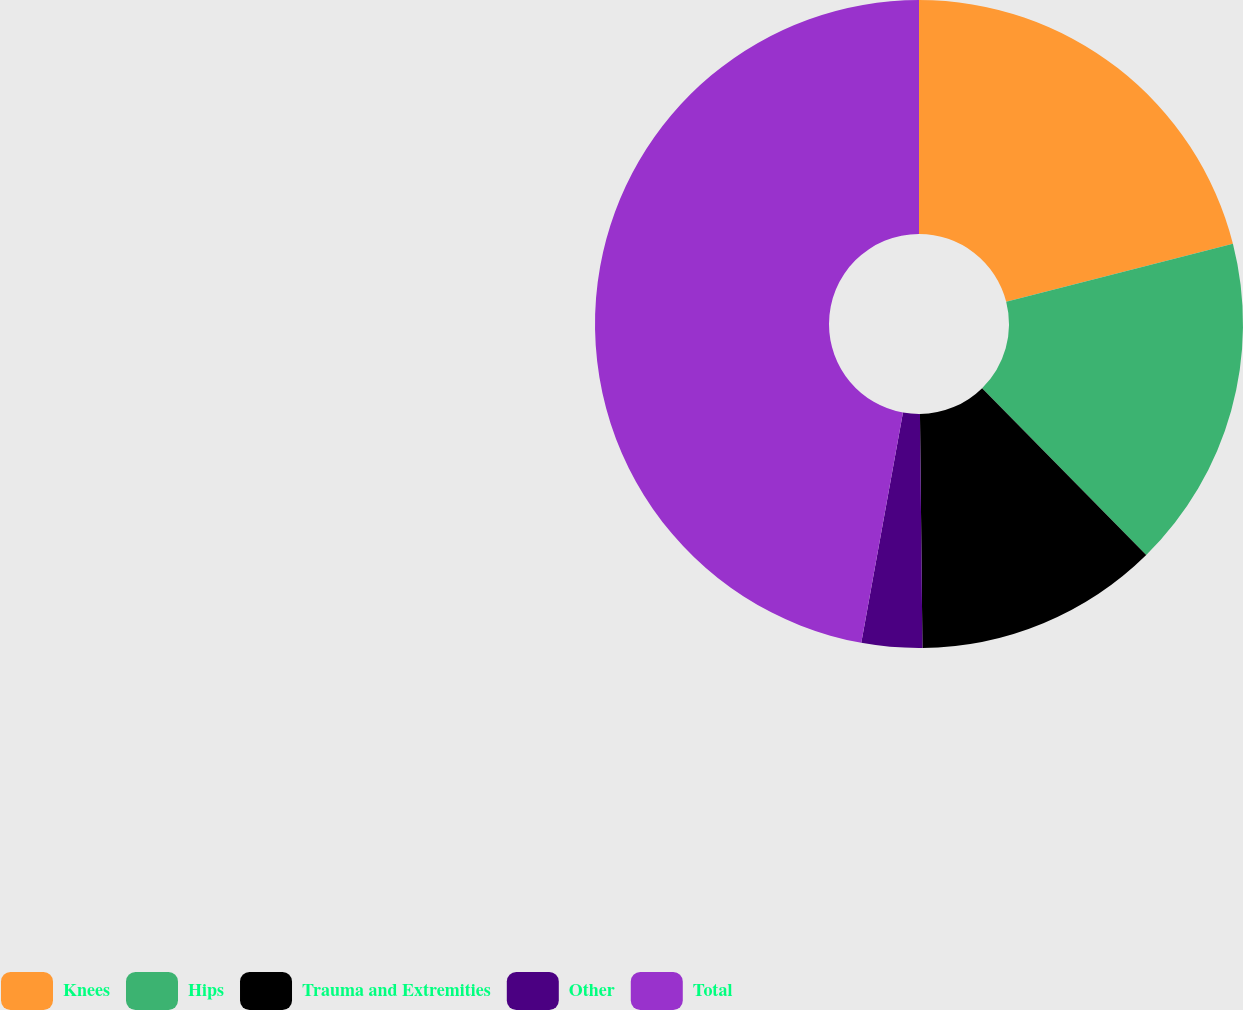Convert chart. <chart><loc_0><loc_0><loc_500><loc_500><pie_chart><fcel>Knees<fcel>Hips<fcel>Trauma and Extremities<fcel>Other<fcel>Total<nl><fcel>21.02%<fcel>16.61%<fcel>12.2%<fcel>3.02%<fcel>47.15%<nl></chart> 